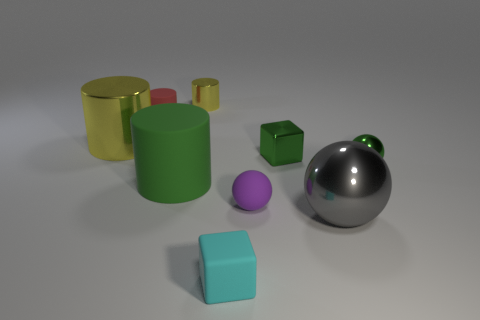Is there a yellow metal cylinder of the same size as the red thing?
Offer a terse response. Yes. What is the material of the big ball that is to the right of the small red thing?
Provide a succinct answer. Metal. What color is the large object that is made of the same material as the big ball?
Your answer should be compact. Yellow. How many matte things are either green objects or small purple spheres?
Keep it short and to the point. 2. What is the shape of the green thing that is the same size as the gray metal thing?
Offer a terse response. Cylinder. How many things are big cylinders that are behind the metal cube or spheres behind the large matte object?
Give a very brief answer. 2. There is a green sphere that is the same size as the rubber block; what is it made of?
Offer a terse response. Metal. How many other objects are the same material as the tiny purple ball?
Offer a terse response. 3. Are there an equal number of green blocks that are in front of the gray metal object and red rubber cylinders that are in front of the big matte thing?
Offer a terse response. Yes. How many green objects are either big matte objects or small shiny blocks?
Your answer should be compact. 2. 